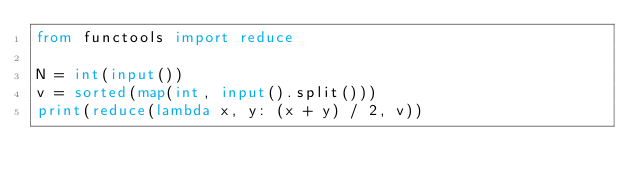Convert code to text. <code><loc_0><loc_0><loc_500><loc_500><_Python_>from functools import reduce

N = int(input())
v = sorted(map(int, input().split()))
print(reduce(lambda x, y: (x + y) / 2, v))</code> 